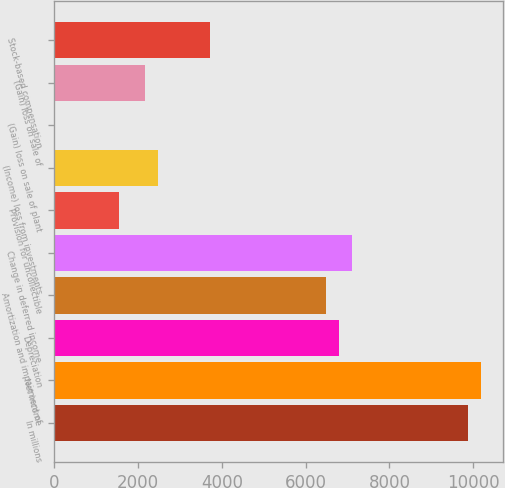<chart> <loc_0><loc_0><loc_500><loc_500><bar_chart><fcel>In millions<fcel>Net income<fcel>Depreciation<fcel>Amortization and impairment of<fcel>Change in deferred income<fcel>Provision for uncollectible<fcel>(Income) loss from investments<fcel>(Gain) loss on sale of plant<fcel>(Gain) loss on sale of<fcel>Stock-based compensation<nl><fcel>9885.8<fcel>10194.7<fcel>6796.8<fcel>6487.9<fcel>7105.7<fcel>1545.5<fcel>2472.2<fcel>1<fcel>2163.3<fcel>3707.8<nl></chart> 